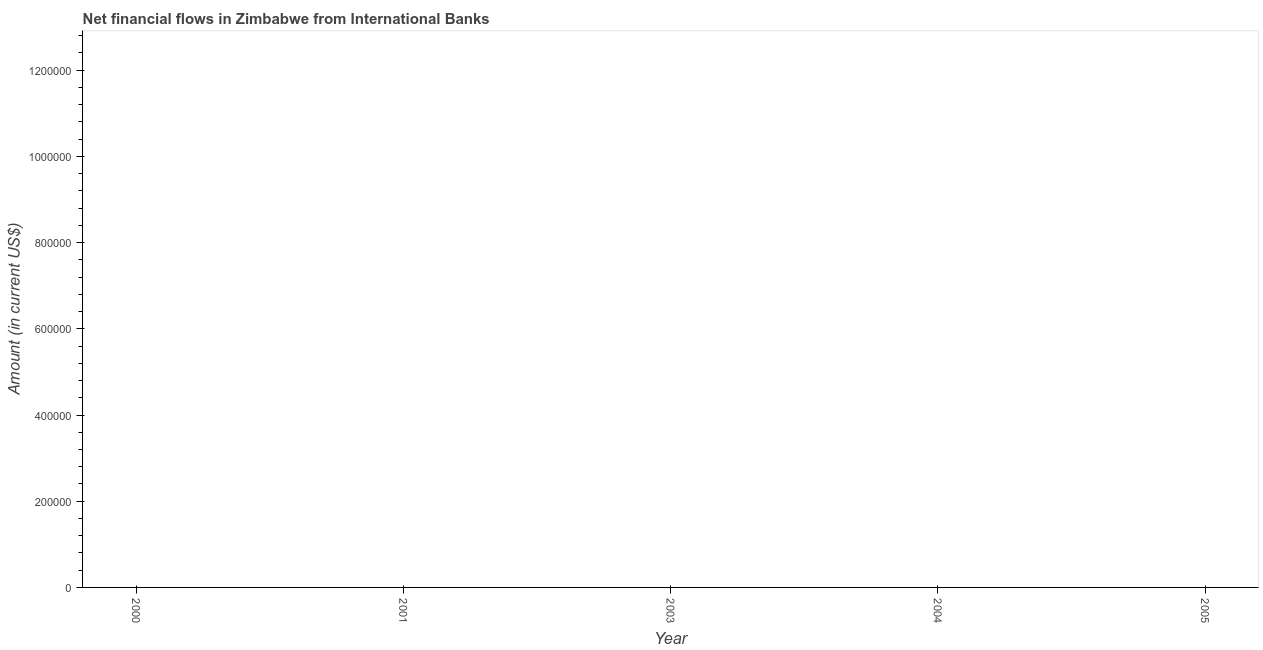What is the net financial flows from ibrd in 2004?
Give a very brief answer. 0. Across all years, what is the minimum net financial flows from ibrd?
Your response must be concise. 0. What is the median net financial flows from ibrd?
Offer a very short reply. 0. In how many years, is the net financial flows from ibrd greater than 1000000 US$?
Offer a very short reply. 0. What is the difference between two consecutive major ticks on the Y-axis?
Your response must be concise. 2.00e+05. Does the graph contain grids?
Provide a succinct answer. No. What is the title of the graph?
Ensure brevity in your answer.  Net financial flows in Zimbabwe from International Banks. What is the label or title of the X-axis?
Ensure brevity in your answer.  Year. What is the label or title of the Y-axis?
Offer a very short reply. Amount (in current US$). What is the Amount (in current US$) of 2001?
Provide a short and direct response. 0. What is the Amount (in current US$) in 2003?
Ensure brevity in your answer.  0. What is the Amount (in current US$) of 2004?
Ensure brevity in your answer.  0. What is the Amount (in current US$) of 2005?
Provide a succinct answer. 0. 